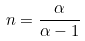Convert formula to latex. <formula><loc_0><loc_0><loc_500><loc_500>n = \frac { \alpha } { \alpha - 1 }</formula> 